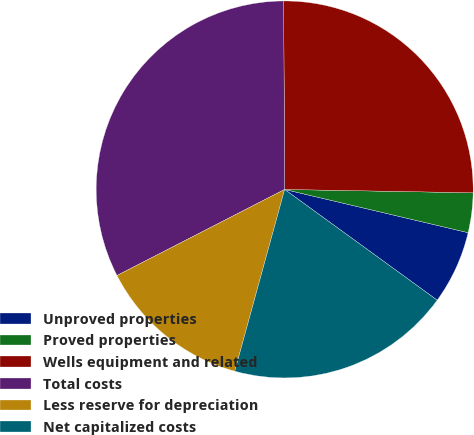<chart> <loc_0><loc_0><loc_500><loc_500><pie_chart><fcel>Unproved properties<fcel>Proved properties<fcel>Wells equipment and related<fcel>Total costs<fcel>Less reserve for depreciation<fcel>Net capitalized costs<nl><fcel>6.31%<fcel>3.4%<fcel>25.37%<fcel>32.46%<fcel>13.19%<fcel>19.27%<nl></chart> 